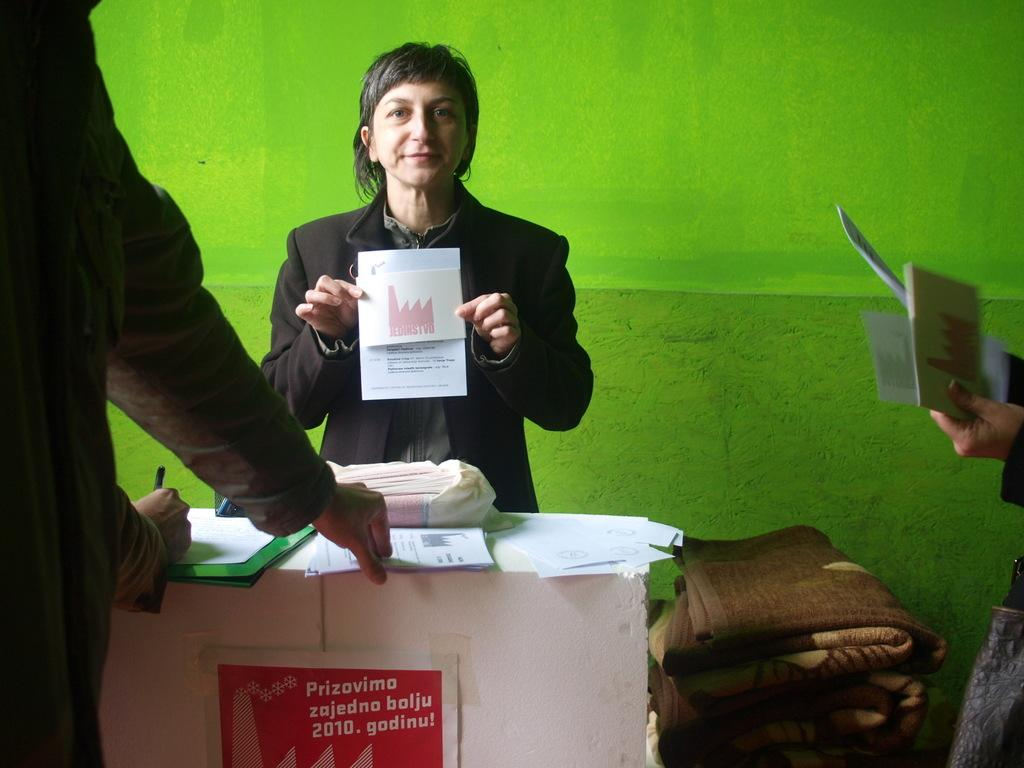What is the woman in the image doing? The woman is standing and holding papers in the image. What is present in the image besides the woman? There is a table and people in front of the table in the image. What are the people doing in front of the table? The people are taking papers in the image. Can you describe the table in the image? There is a table in the image, but no specific details about its appearance are provided. Where is the drawer located in the image? There is no drawer present in the image. What type of carriage is visible in the image? There is no carriage present in the image. 